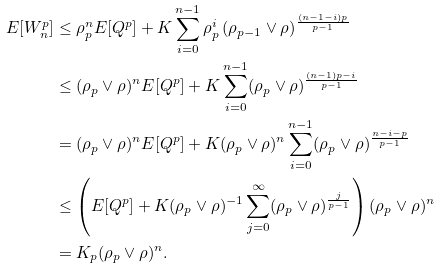<formula> <loc_0><loc_0><loc_500><loc_500>E [ W _ { n } ^ { p } ] & \leq \rho _ { p } ^ { n } E [ Q ^ { p } ] + K \sum _ { i = 0 } ^ { n - 1 } \rho _ { p } ^ { i } \, ( \rho _ { p - 1 } \vee \rho ) ^ { \frac { ( n - 1 - i ) p } { p - 1 } } \\ & \leq ( \rho _ { p } \vee \rho ) ^ { n } E [ Q ^ { p } ] + K \sum _ { i = 0 } ^ { n - 1 } ( \rho _ { p } \vee \rho ) ^ { \frac { ( n - 1 ) p - i } { p - 1 } } \\ & = ( \rho _ { p } \vee \rho ) ^ { n } E [ Q ^ { p } ] + K ( \rho _ { p } \vee \rho ) ^ { n } \sum _ { i = 0 } ^ { n - 1 } ( \rho _ { p } \vee \rho ) ^ { \frac { n - i - p } { p - 1 } } \\ & \leq \left ( E [ Q ^ { p } ] + K ( \rho _ { p } \vee \rho ) ^ { - 1 } \sum _ { j = 0 } ^ { \infty } ( \rho _ { p } \vee \rho ) ^ { \frac { j } { p - 1 } } \right ) ( \rho _ { p } \vee \rho ) ^ { n } \\ & = K _ { p } ( \rho _ { p } \vee \rho ) ^ { n } .</formula> 